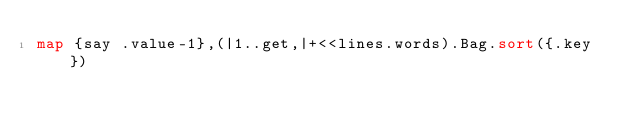Convert code to text. <code><loc_0><loc_0><loc_500><loc_500><_Perl_>map {say .value-1},(|1..get,|+<<lines.words).Bag.sort({.key})</code> 